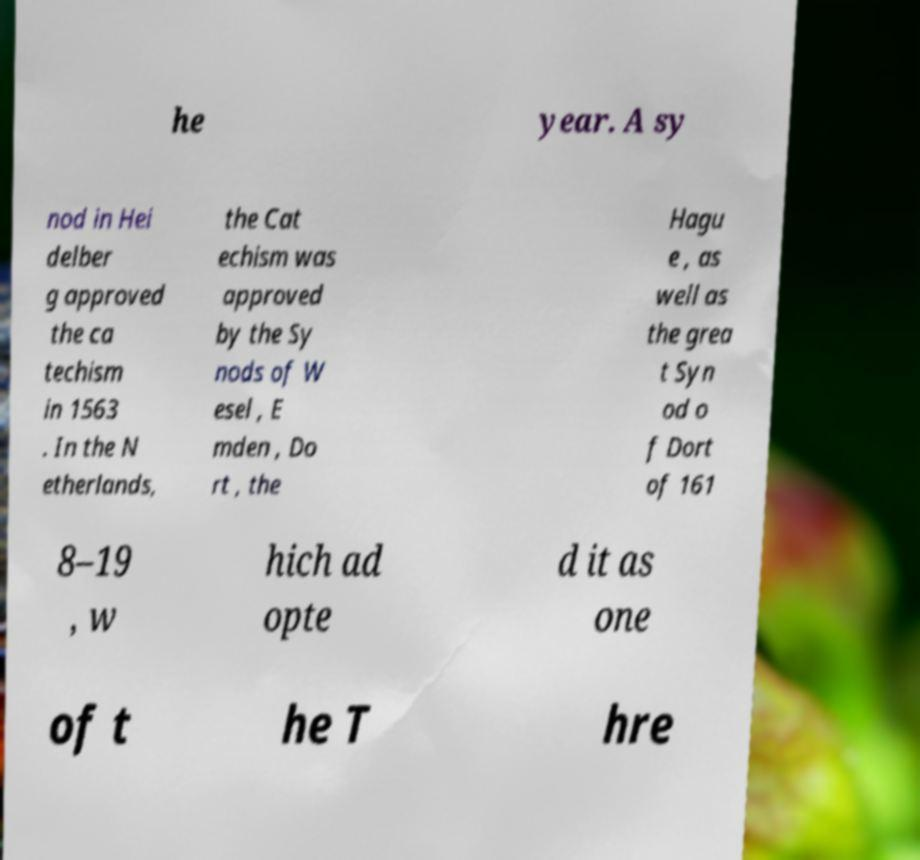Can you accurately transcribe the text from the provided image for me? he year. A sy nod in Hei delber g approved the ca techism in 1563 . In the N etherlands, the Cat echism was approved by the Sy nods of W esel , E mden , Do rt , the Hagu e , as well as the grea t Syn od o f Dort of 161 8–19 , w hich ad opte d it as one of t he T hre 